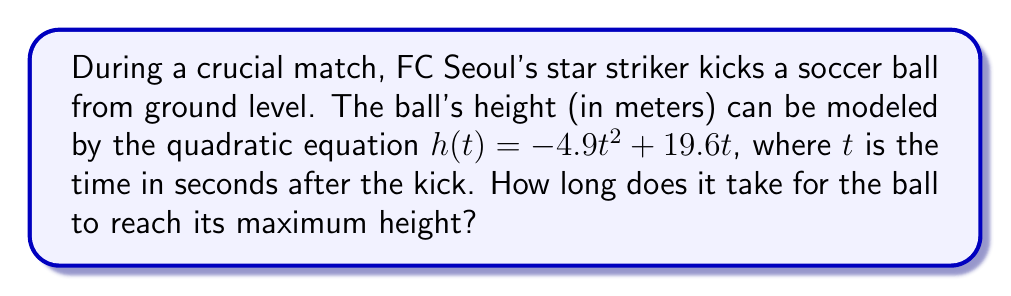Teach me how to tackle this problem. To find the time when the ball reaches its maximum height, we need to follow these steps:

1) The quadratic equation given is $h(t) = -4.9t^2 + 19.6t$

2) In a quadratic function $f(x) = ax^2 + bx + c$, the x-coordinate of the vertex (which represents the maximum or minimum point) is given by $x = -\frac{b}{2a}$

3) In our case, $a = -4.9$ and $b = 19.6$

4) Substituting these values into the formula:

   $t = -\frac{19.6}{2(-4.9)} = \frac{19.6}{9.8} = 2$

5) Therefore, the ball reaches its maximum height 2 seconds after it's kicked.

To verify, we can calculate the height at 1.9s, 2s, and 2.1s:

$h(1.9) = -4.9(1.9)^2 + 19.6(1.9) = 18.62$ m
$h(2.0) = -4.9(2.0)^2 + 19.6(2.0) = 19.60$ m
$h(2.1) = -4.9(2.1)^2 + 19.6(2.1) = 18.62$ m

This confirms that the maximum height occurs at 2 seconds.
Answer: 2 seconds 